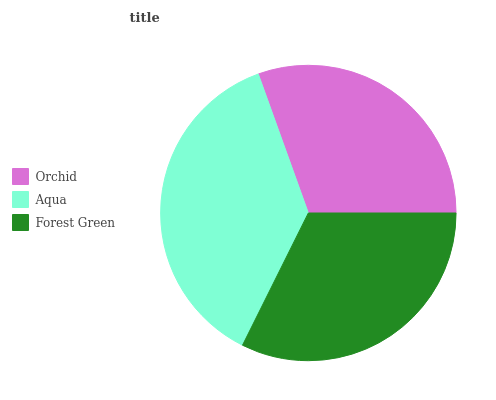Is Orchid the minimum?
Answer yes or no. Yes. Is Aqua the maximum?
Answer yes or no. Yes. Is Forest Green the minimum?
Answer yes or no. No. Is Forest Green the maximum?
Answer yes or no. No. Is Aqua greater than Forest Green?
Answer yes or no. Yes. Is Forest Green less than Aqua?
Answer yes or no. Yes. Is Forest Green greater than Aqua?
Answer yes or no. No. Is Aqua less than Forest Green?
Answer yes or no. No. Is Forest Green the high median?
Answer yes or no. Yes. Is Forest Green the low median?
Answer yes or no. Yes. Is Aqua the high median?
Answer yes or no. No. Is Orchid the low median?
Answer yes or no. No. 